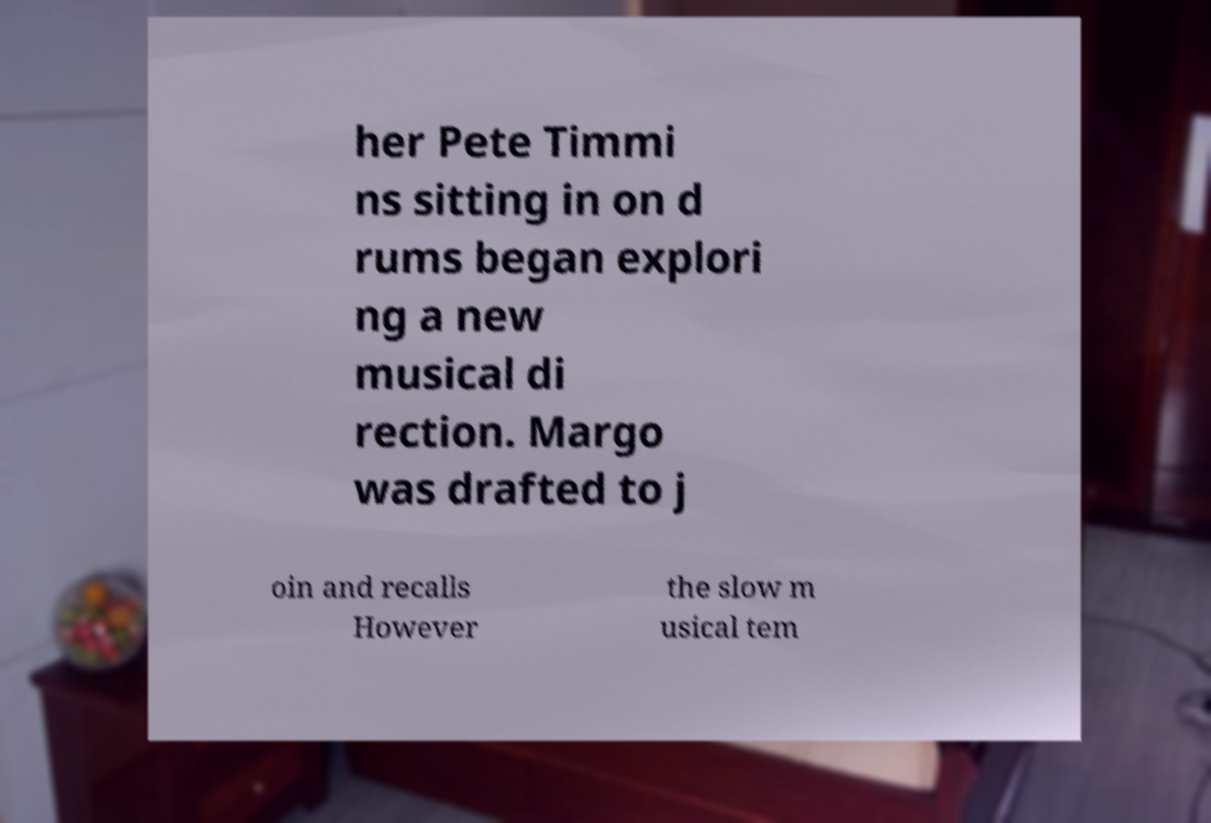Could you extract and type out the text from this image? her Pete Timmi ns sitting in on d rums began explori ng a new musical di rection. Margo was drafted to j oin and recalls However the slow m usical tem 